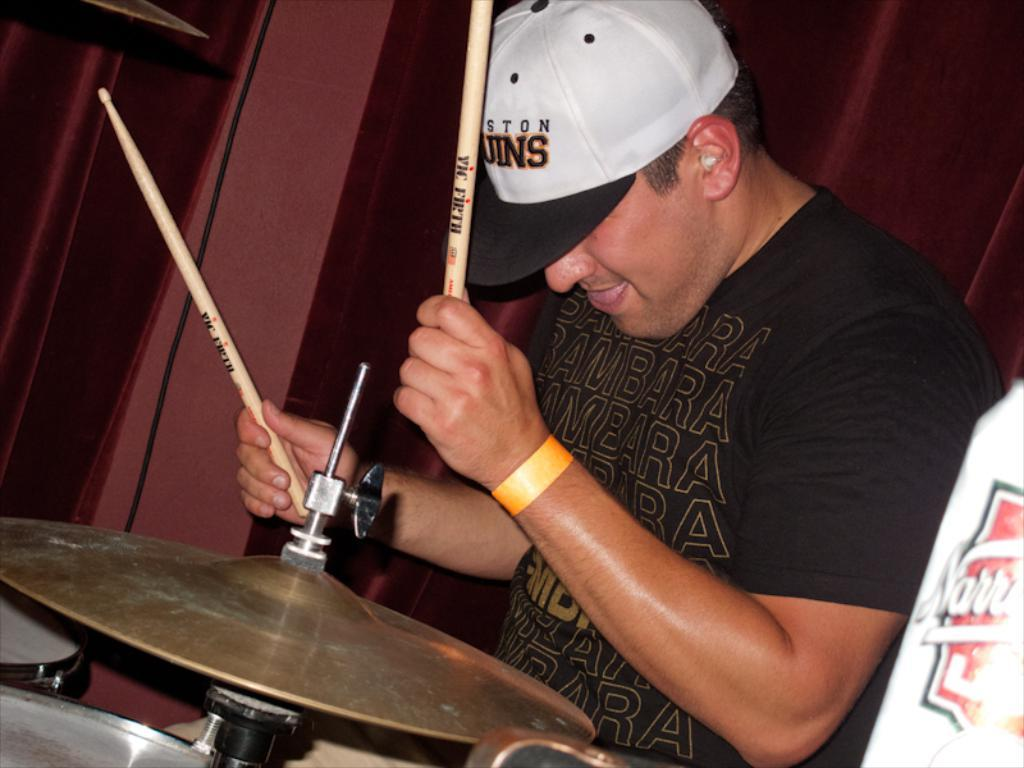<image>
Give a short and clear explanation of the subsequent image. The drummer's drum sticks have the name Vic Firth on them. 